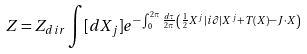<formula> <loc_0><loc_0><loc_500><loc_500>Z = Z _ { d i r } \int [ d X _ { j } ] e ^ { - \int _ { 0 } ^ { 2 \pi } \frac { d \tau } { 2 \pi } \left ( \frac { 1 } { 2 } X ^ { j } | i \partial | X ^ { j } + T ( X ) - J \cdot X \right ) }</formula> 